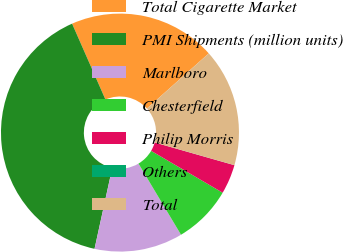Convert chart. <chart><loc_0><loc_0><loc_500><loc_500><pie_chart><fcel>Total Cigarette Market<fcel>PMI Shipments (million units)<fcel>Marlboro<fcel>Chesterfield<fcel>Philip Morris<fcel>Others<fcel>Total<nl><fcel>20.0%<fcel>39.98%<fcel>12.0%<fcel>8.0%<fcel>4.01%<fcel>0.01%<fcel>16.0%<nl></chart> 